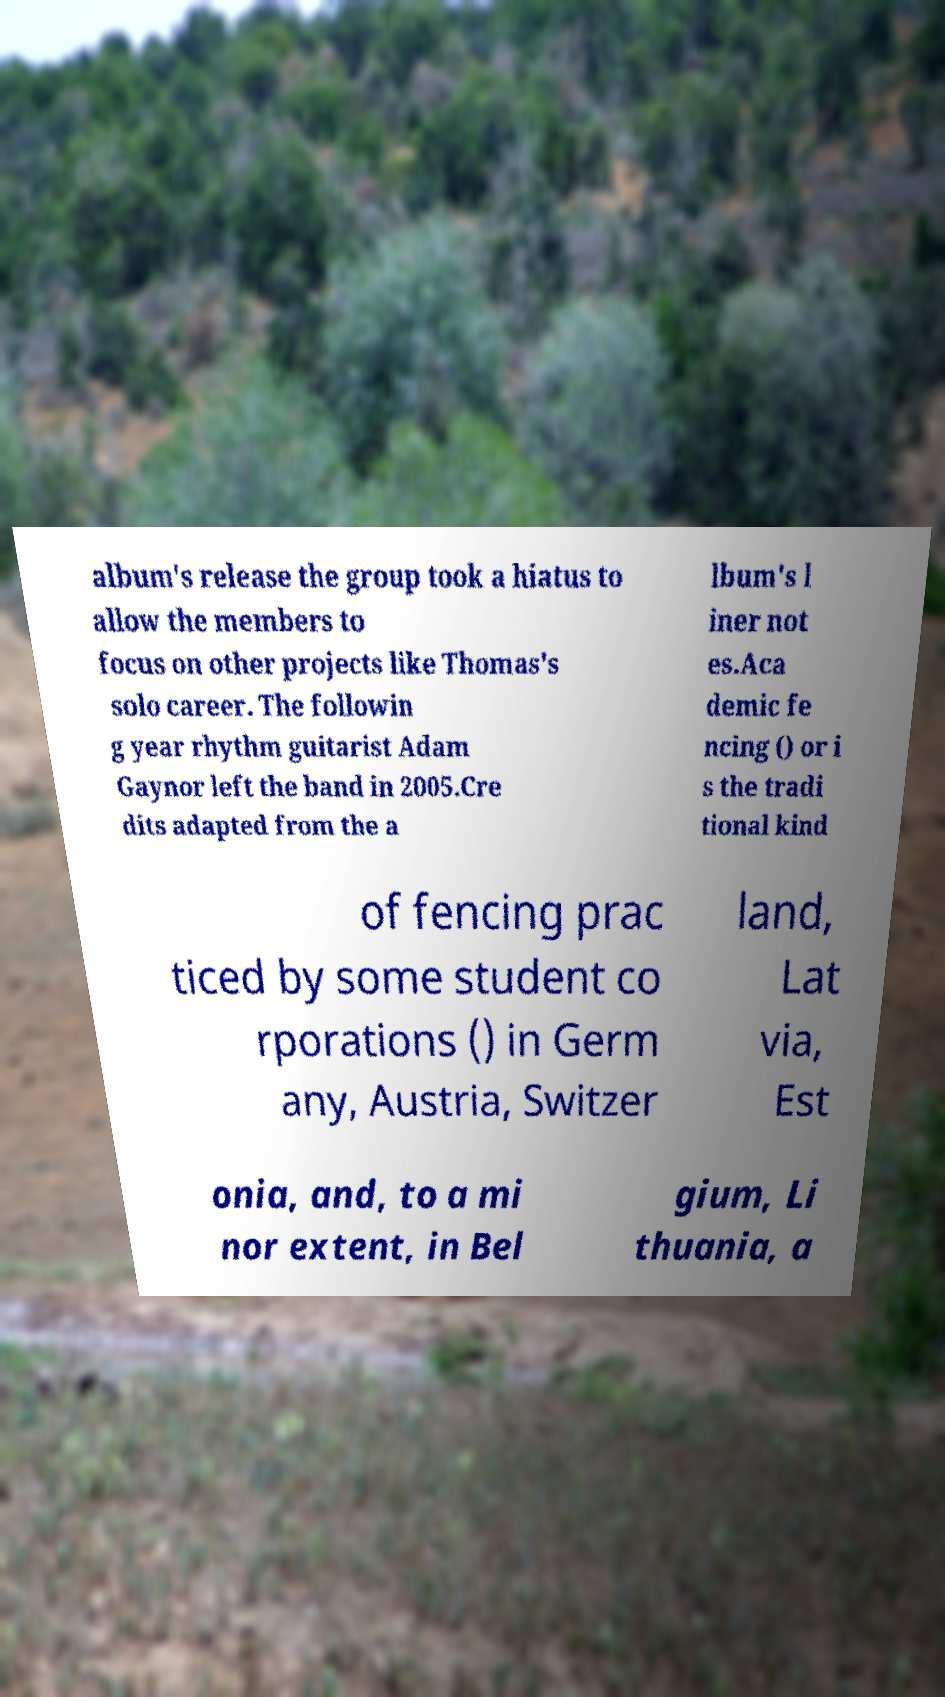I need the written content from this picture converted into text. Can you do that? album's release the group took a hiatus to allow the members to focus on other projects like Thomas's solo career. The followin g year rhythm guitarist Adam Gaynor left the band in 2005.Cre dits adapted from the a lbum's l iner not es.Aca demic fe ncing () or i s the tradi tional kind of fencing prac ticed by some student co rporations () in Germ any, Austria, Switzer land, Lat via, Est onia, and, to a mi nor extent, in Bel gium, Li thuania, a 